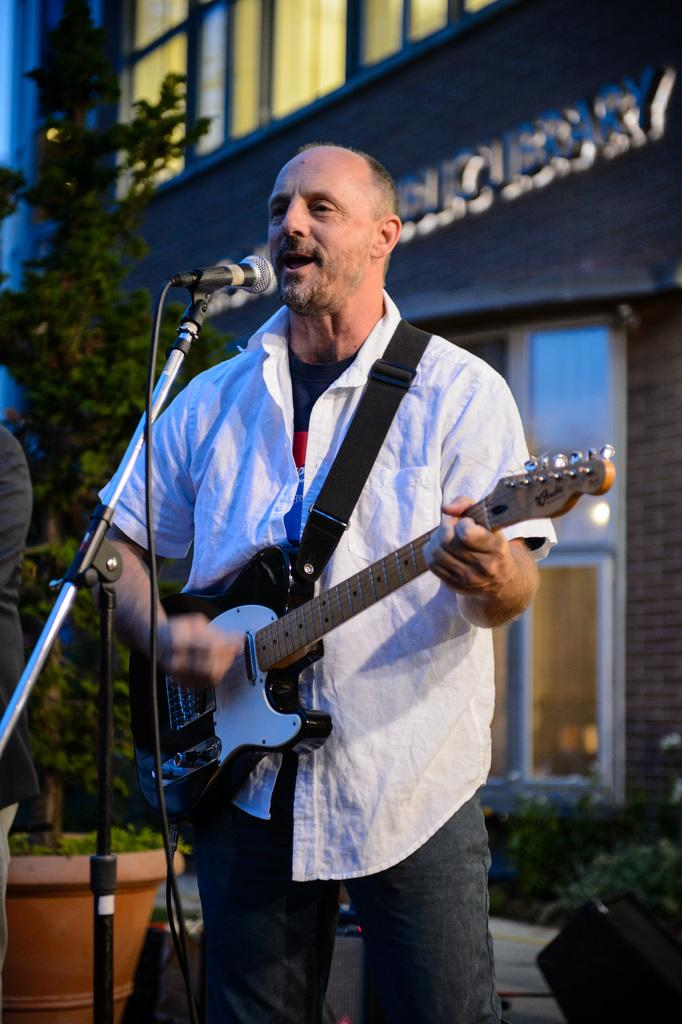What is the man in the image doing? The man is playing a guitar and singing into a microphone. What is the man's posture in the image? The man is standing. What can be seen in the background of the image? There is a tree, a building, and plants in the background of the image. What type of quilt is being used as a stage prop in the image? There is no quilt present in the image; it features a man playing a guitar and singing into a microphone. Where is the meeting taking place in the image? There is no meeting depicted in the image; it shows a man playing a guitar and singing into a microphone. 